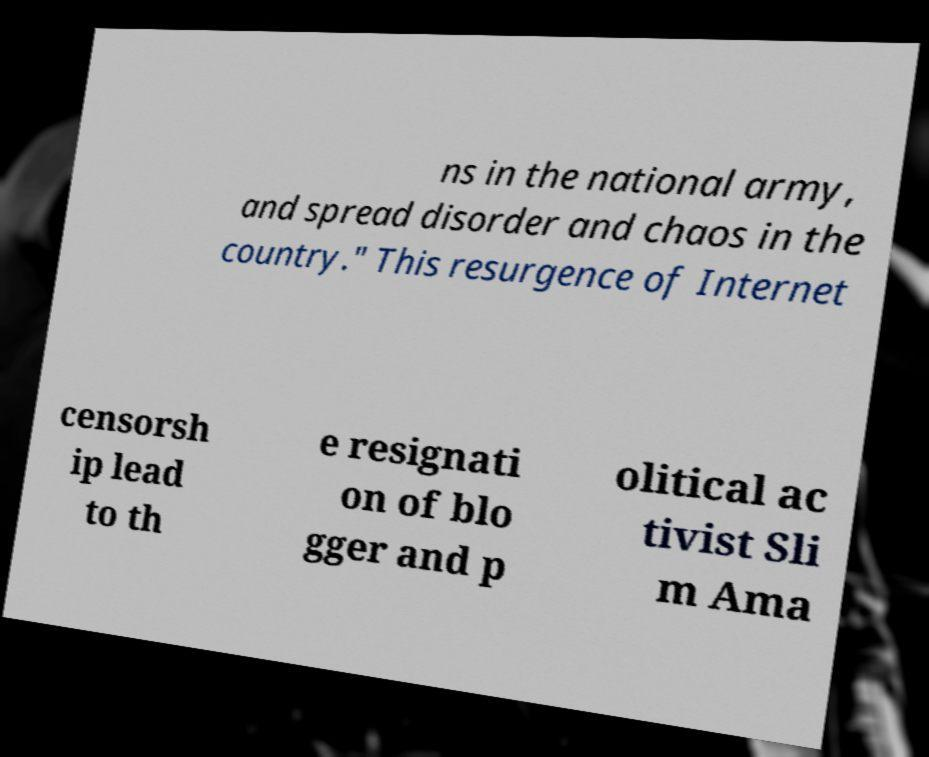Could you extract and type out the text from this image? ns in the national army, and spread disorder and chaos in the country." This resurgence of Internet censorsh ip lead to th e resignati on of blo gger and p olitical ac tivist Sli m Ama 